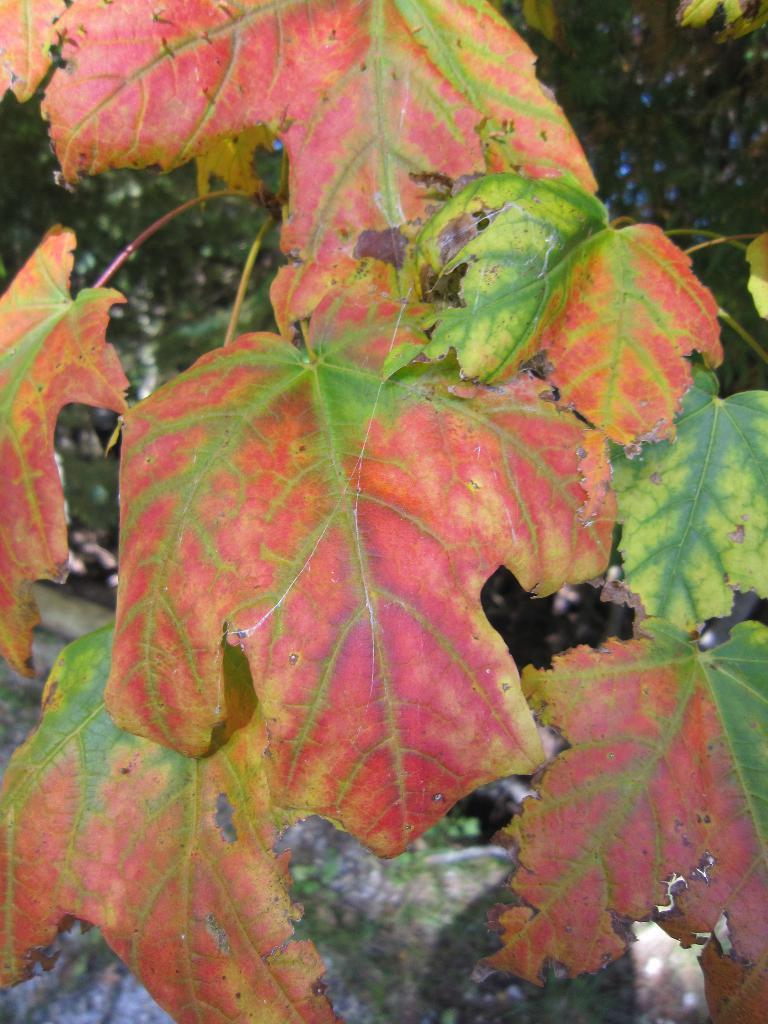How would you summarize this image in a sentence or two? In the foreground of the picture there are leaves. The background is blurred. In the background there are trees and a rock. 